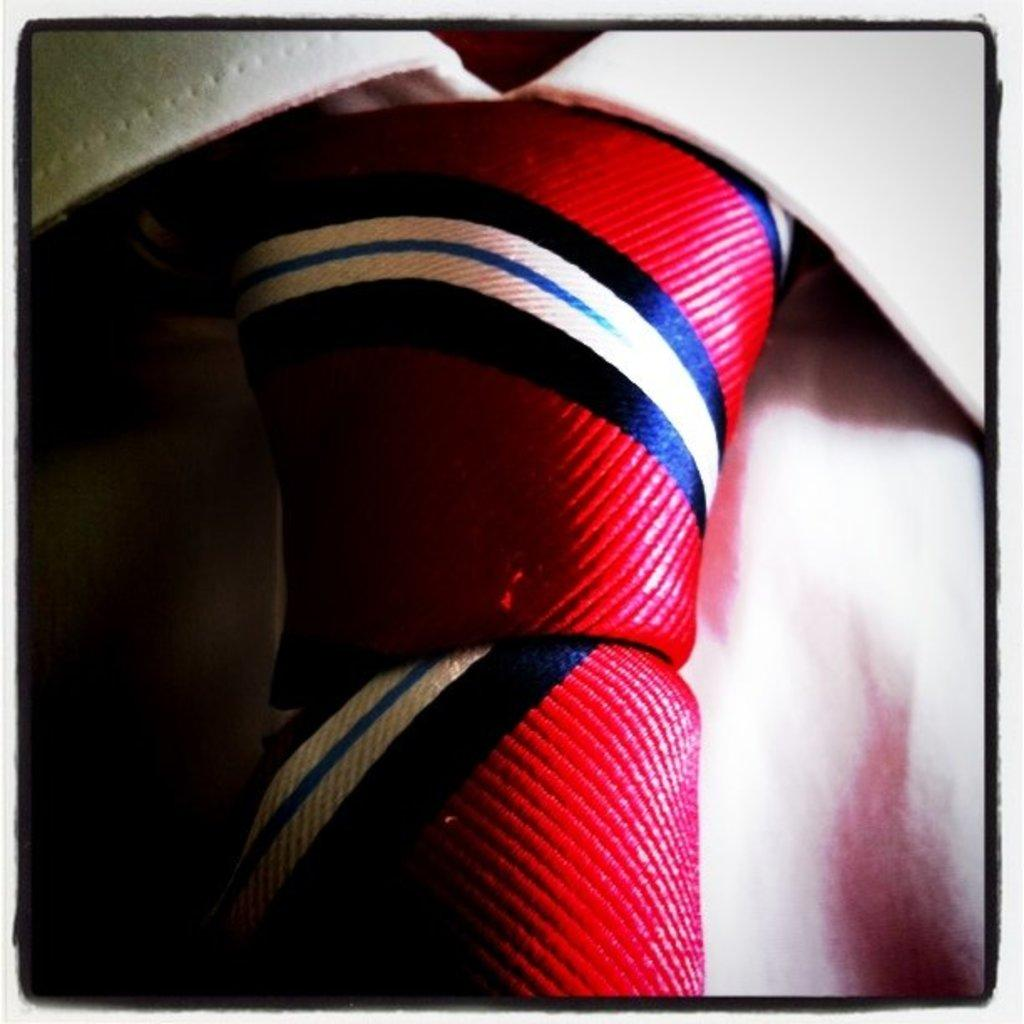What type of clothing item is in the image? There is a white shirt in the image. What accessory is on the shirt? There is a red tie on the shirt. Can you describe the tie in more detail? The tie has stripes. What type of map can be seen on the shirt in the image? There is no map present on the shirt in the image; it features a red tie with stripes on a white shirt. 